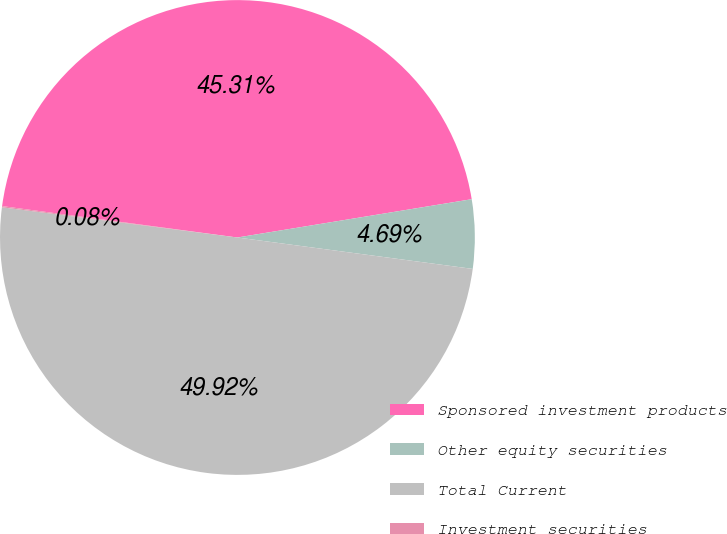Convert chart. <chart><loc_0><loc_0><loc_500><loc_500><pie_chart><fcel>Sponsored investment products<fcel>Other equity securities<fcel>Total Current<fcel>Investment securities<nl><fcel>45.31%<fcel>4.69%<fcel>49.92%<fcel>0.08%<nl></chart> 